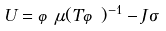Convert formula to latex. <formula><loc_0><loc_0><loc_500><loc_500>\ U = \varphi \mu ( T \varphi ) ^ { - 1 } - J \sigma \</formula> 